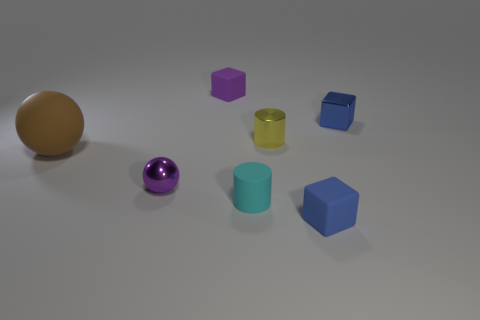Subtract all tiny rubber cubes. How many cubes are left? 1 Add 3 brown matte things. How many objects exist? 10 Subtract all spheres. How many objects are left? 5 Subtract all small gray rubber spheres. Subtract all tiny metal blocks. How many objects are left? 6 Add 3 metal cubes. How many metal cubes are left? 4 Add 4 big red matte blocks. How many big red matte blocks exist? 4 Subtract 0 red cylinders. How many objects are left? 7 